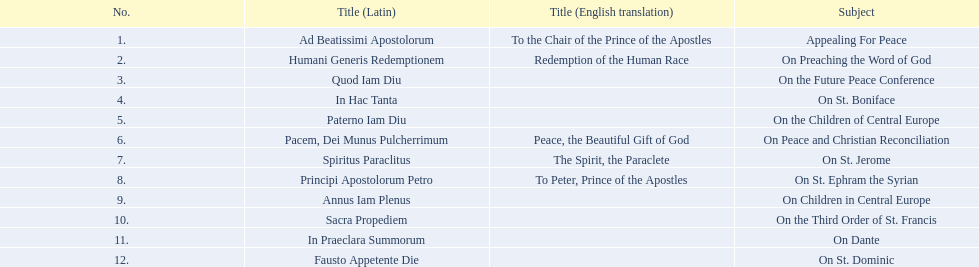What was the number of encyclopedias that had subjects relating specifically to children? 2. 